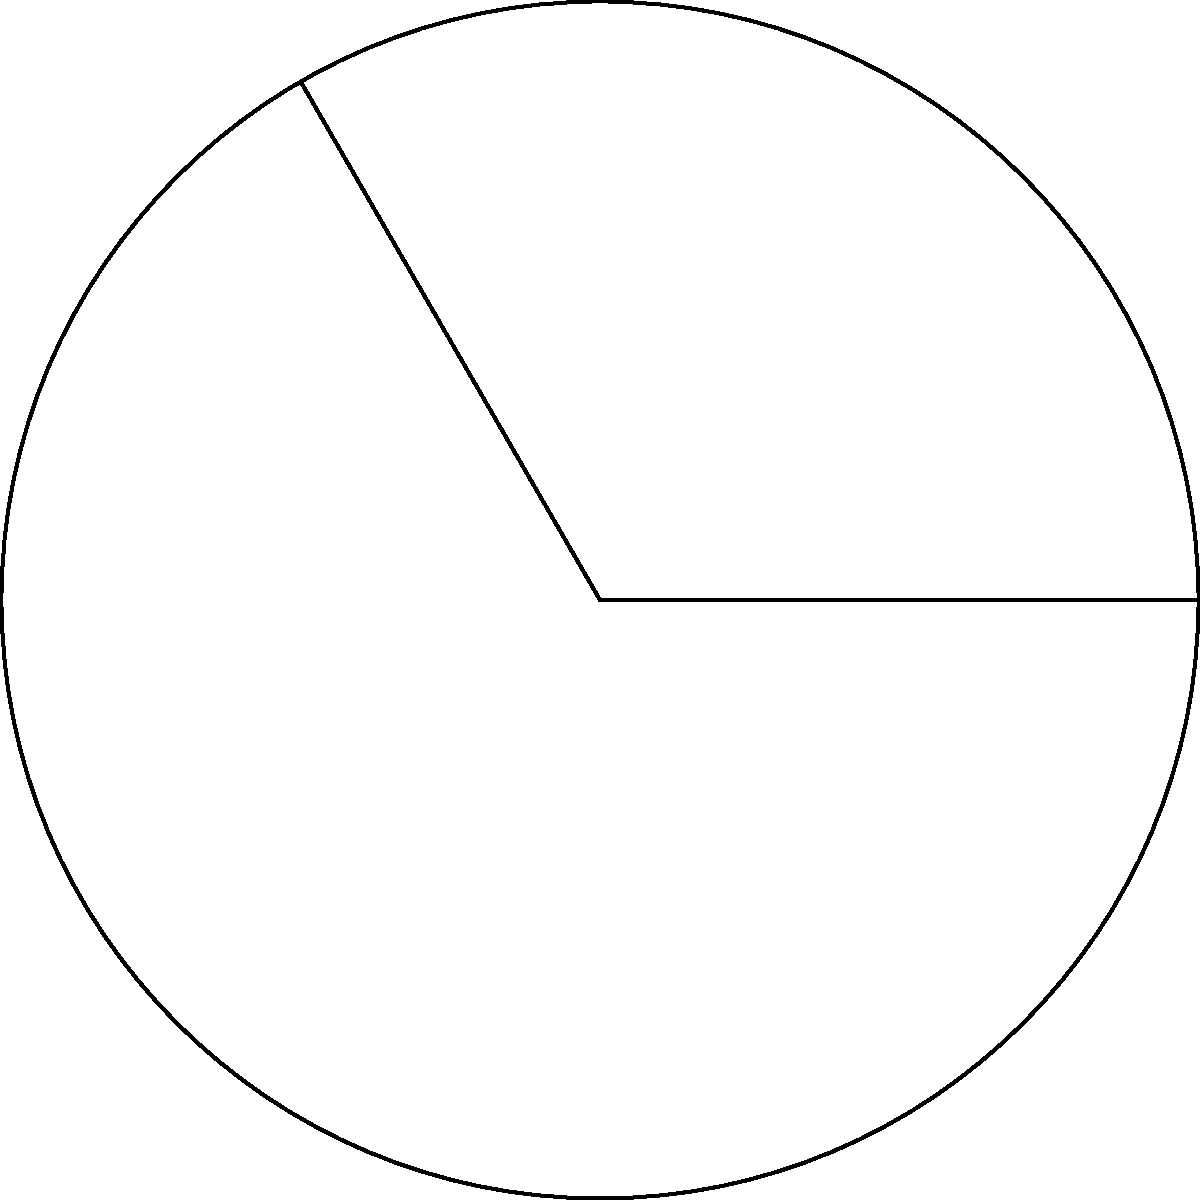The FK Sarajevo stadium has a circular running track around its soccer pitch. If the radius of the track is 50 meters and a runner covers an arc of 120°, what is the length of the arc the runner has traveled? Let's approach this step-by-step:

1) First, recall the formula for arc length:
   Arc length = $\frac{\theta}{360°} \cdot 2\pi r$
   where $\theta$ is the central angle in degrees and $r$ is the radius.

2) We are given:
   - Radius (r) = 50 meters
   - Central angle ($\theta$) = 120°

3) Let's substitute these values into our formula:
   Arc length = $\frac{120°}{360°} \cdot 2\pi \cdot 50$

4) Simplify the fraction:
   Arc length = $\frac{1}{3} \cdot 2\pi \cdot 50$

5) Calculate:
   Arc length = $\frac{2\pi \cdot 50}{3}$
              = $\frac{100\pi}{3}$
              ≈ 104.72 meters

Therefore, the runner has traveled approximately 104.72 meters along the arc.
Answer: $\frac{100\pi}{3}$ meters or approximately 104.72 meters 